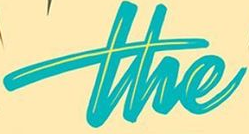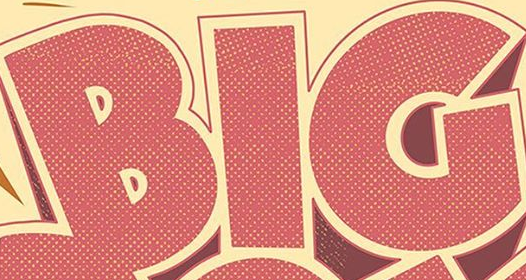What words are shown in these images in order, separated by a semicolon? the; BIG 